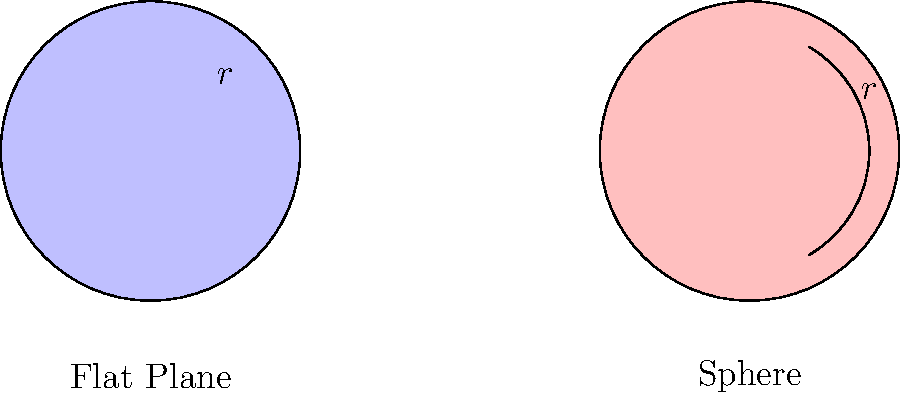In your latest screenplay about a mathematician exploring alternate dimensions, you need to explain the difference between circular areas on a flat plane versus a sphere. If a circle with radius $r$ on a flat plane has an area of $\pi r^2$, what is the formula for the area of a circle with the same radius $r$ on the surface of a sphere with radius $R$, where $r < R$? Let's approach this step-by-step, imagining how we'd explain it to the visual effects team:

1) On a flat plane, the area of a circle is simply $A_{flat} = \pi r^2$.

2) On a sphere, however, the surface is curved. This curvature affects the area calculation.

3) The key concept here is the solid angle. On a sphere, a circle forms a "cap," and its area is proportional to the solid angle it subtends at the center of the sphere.

4) The solid angle of a spherical cap is given by $\Omega = 2\pi(1 - \cos\theta)$, where $\theta$ is the angle between the radius to the center of the cap and the radius to the edge of the cap.

5) We can find $\cos\theta$ using the right triangle formed by $R$, $r$, and $R-h$, where $h$ is the height of the cap:

   $\cos\theta = \frac{R-h}{R} = 1 - \frac{h}{R}$

6) The height $h$ can be found using the Pythagorean theorem:

   $R^2 = (R-h)^2 + r^2$
   $R^2 = R^2 - 2Rh + h^2 + r^2$
   $2Rh - h^2 = r^2$
   $h \approx \frac{r^2}{2R}$ (for small $r$)

7) Substituting this back into the cosine equation:

   $\cos\theta \approx 1 - \frac{r^2}{2R^2}$

8) Now we can calculate the solid angle:

   $\Omega \approx 2\pi(1 - (1 - \frac{r^2}{2R^2})) = \frac{\pi r^2}{R^2}$

9) The area of the spherical cap is this solid angle multiplied by $R^2$:

   $A_{sphere} = R^2 \cdot \frac{\pi r^2}{R^2} = \pi r^2$

Therefore, surprisingly, the area of a small circle on a sphere is approximately the same as on a flat plane!
Answer: $A_{sphere} \approx \pi r^2$ 